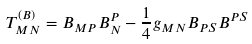<formula> <loc_0><loc_0><loc_500><loc_500>T _ { M N } ^ { ( B ) } = B _ { M P } B _ { N } ^ { P } - \frac { 1 } { 4 } g _ { M N } B _ { P S } B ^ { P S }</formula> 